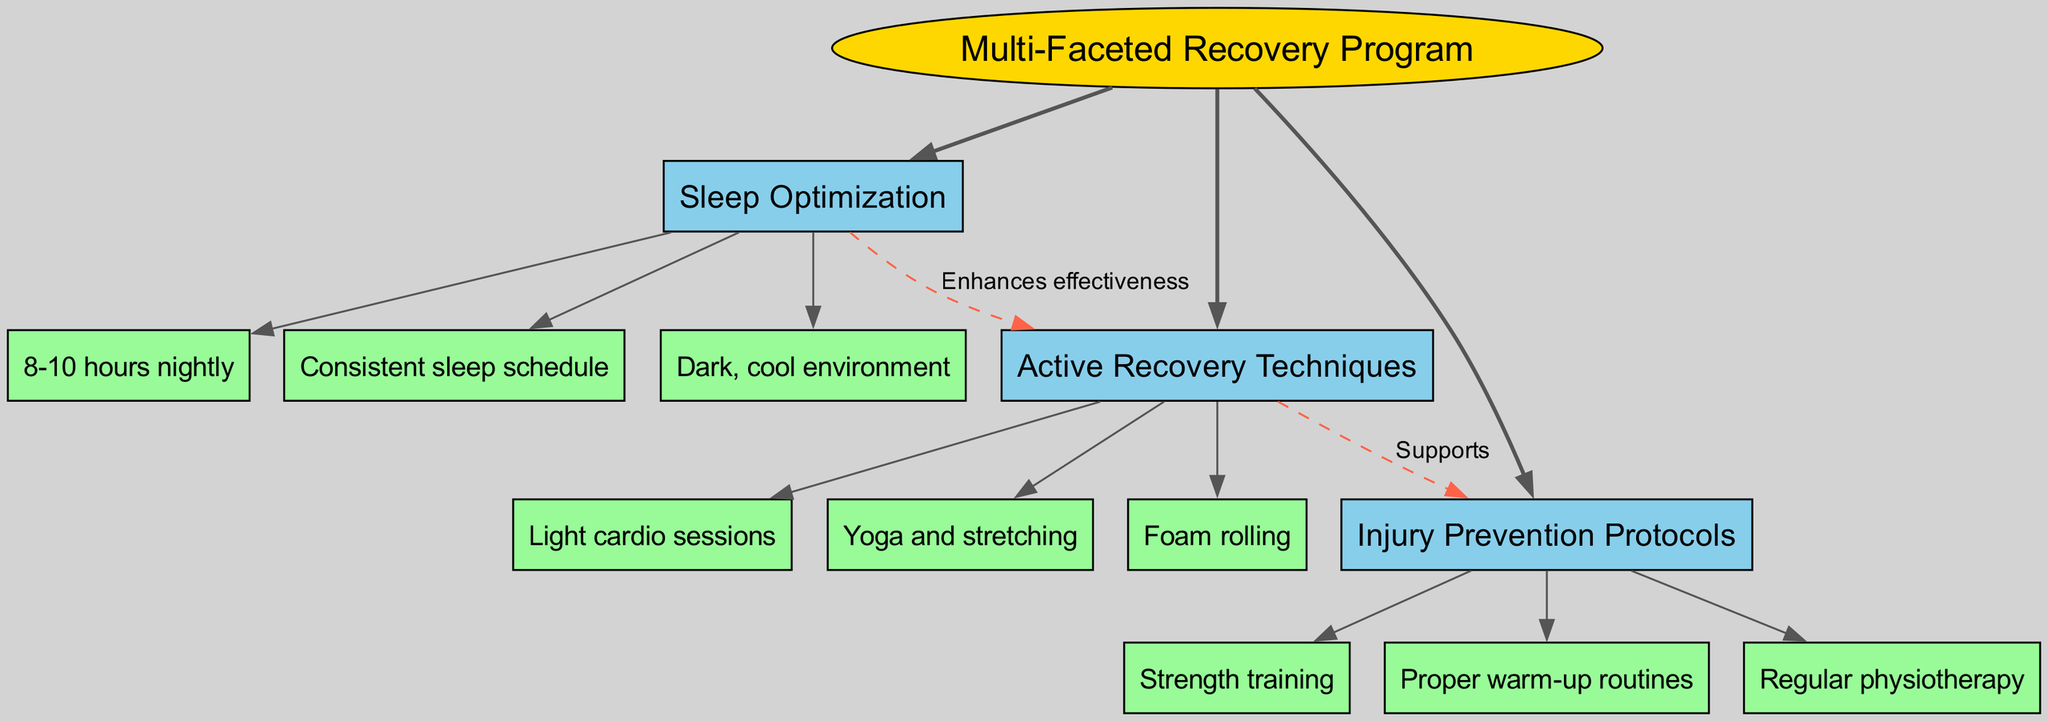What is the central topic of the diagram? The central topic is explicitly labeled at the top of the diagram within an ellipse. It represents the main focus of the entire diagram.
Answer: Multi-Faceted Recovery Program How many main branches does the diagram have? The diagram features three main branches that are directly connected to the central topic, outlining key components of the recovery program.
Answer: 3 What technique is listed under "Active Recovery Techniques"? "Active Recovery Techniques" has multiple sub-branches, one of which is specifically noted as a technique. Looking through the sub-branches, we can find several options that fall under this category.
Answer: Light cardio sessions Which branch enhances the effectiveness of the other branches? The label on the edge connecting the "Sleep Optimization" branch to the "Active Recovery Techniques" indicates that sleep optimization enhances the effectiveness of active recovery.
Answer: Enhances effectiveness What supports the injury prevention protocols according to the diagram? The specific connection mentioned in the diagram indicates that "Active Recovery Techniques" support the "Injury Prevention Protocols," highlighting their interrelation.
Answer: Supports What are two components of injury prevention protocols? By reviewing the sub-branches under "Injury Prevention Protocols," we can identify multiple components within them to answer the question.
Answer: Strength training, Proper warm-up routines How is "Sleep Optimization" related to "Active Recovery Techniques"? The diagram includes a dashed edge showing the relation between "Sleep Optimization" and "Active Recovery Techniques," indicating that sleep optimization enhances the effectiveness of active recovery techniques.
Answer: Enhances effectiveness What color are the main branches represented in the diagram? Each main branch is shown in a specific color, which can be derived directly from the style settings in the diagram, reinforcing the visual theme and categorization.
Answer: Light blue What is the purpose of the connections between branches? The connections between branches illustrate relationships, such as enhancement or support, highlighting how different elements of the recovery program interact and affect each other's effectiveness.
Answer: To illustrate relationships 